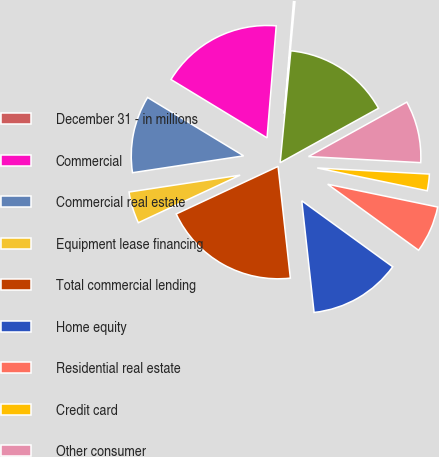Convert chart. <chart><loc_0><loc_0><loc_500><loc_500><pie_chart><fcel>December 31 - in millions<fcel>Commercial<fcel>Commercial real estate<fcel>Equipment lease financing<fcel>Total commercial lending<fcel>Home equity<fcel>Residential real estate<fcel>Credit card<fcel>Other consumer<fcel>Total consumer lending<nl><fcel>0.21%<fcel>17.61%<fcel>11.09%<fcel>4.56%<fcel>19.79%<fcel>13.26%<fcel>6.74%<fcel>2.39%<fcel>8.91%<fcel>15.44%<nl></chart> 